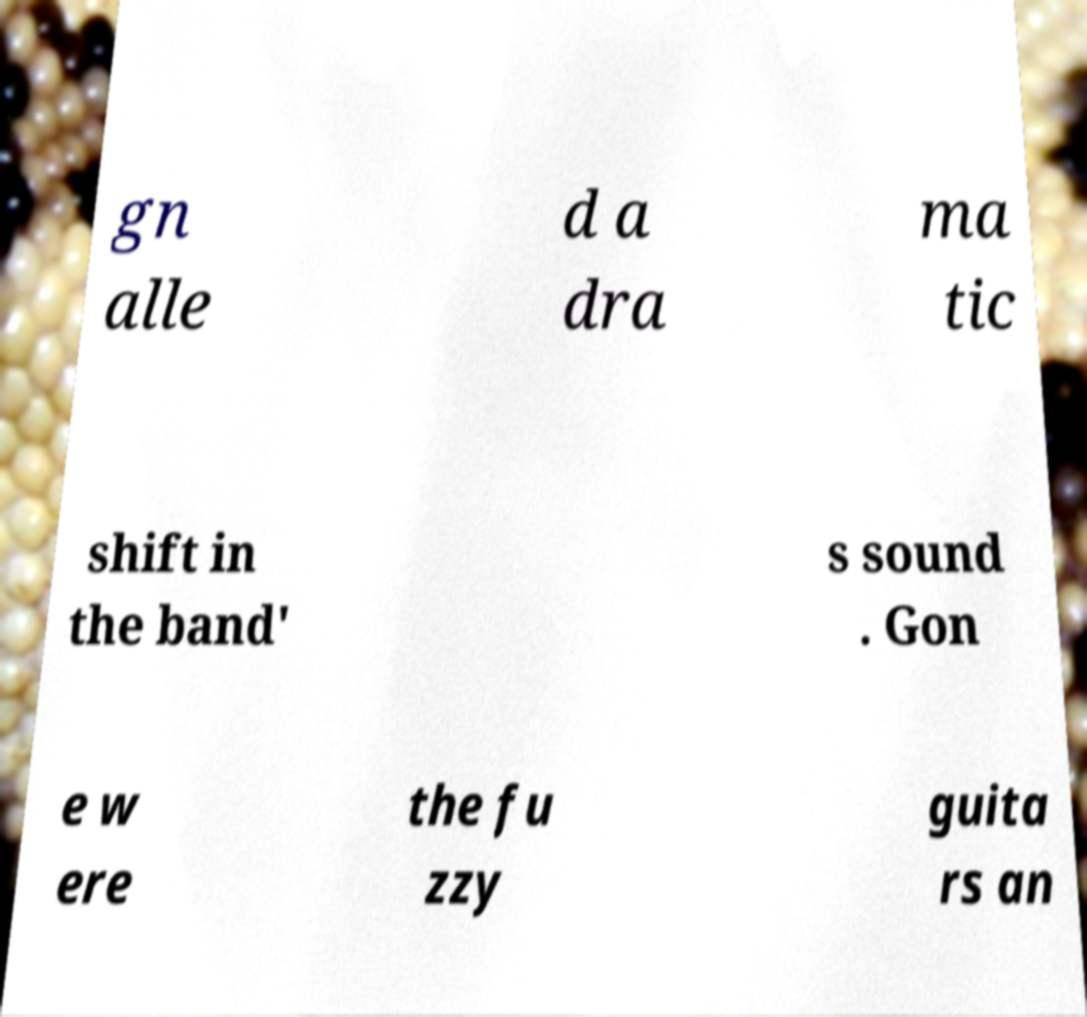For documentation purposes, I need the text within this image transcribed. Could you provide that? gn alle d a dra ma tic shift in the band' s sound . Gon e w ere the fu zzy guita rs an 